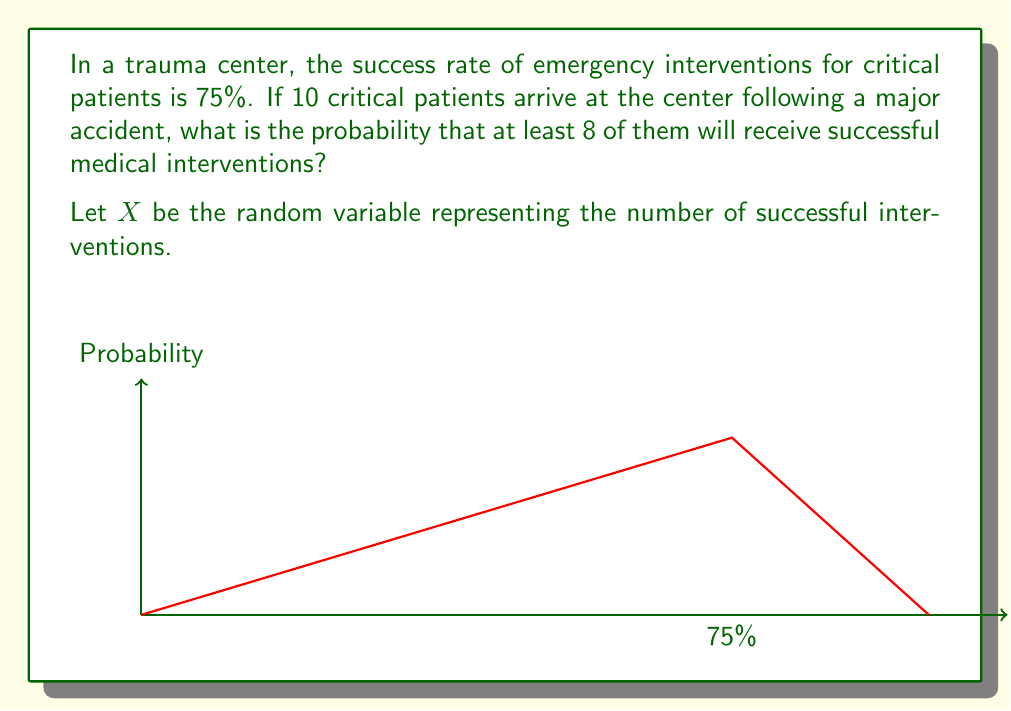Provide a solution to this math problem. To solve this problem, we'll use the binomial distribution, as we have a fixed number of independent trials (patients) with a constant probability of success for each trial.

1) First, we identify the parameters:
   n = 10 (number of patients)
   p = 0.75 (probability of successful intervention)
   q = 1 - p = 0.25 (probability of unsuccessful intervention)

2) We need to find P(X ≥ 8), which is equivalent to:
   P(X = 8) + P(X = 9) + P(X = 10)

3) The probability mass function for the binomial distribution is:
   $$P(X = k) = \binom{n}{k} p^k q^{n-k}$$

4) Let's calculate each probability:

   For X = 8:
   $$P(X = 8) = \binom{10}{8} (0.75)^8 (0.25)^2 = 45 \cdot 0.1001129150 \cdot 0.0625 = 0.2815300293$$

   For X = 9:
   $$P(X = 9) = \binom{10}{9} (0.75)^9 (0.25)^1 = 10 \cdot 0.0750846862 \cdot 0.25 = 0.1877117155$$

   For X = 10:
   $$P(X = 10) = \binom{10}{10} (0.75)^{10} (0.25)^0 = 1 \cdot 0.0563130147 \cdot 1 = 0.0563130147$$

5) Sum these probabilities:
   P(X ≥ 8) = 0.2815300293 + 0.1877117155 + 0.0563130147 = 0.5255547595

Therefore, the probability that at least 8 out of 10 critical patients will receive successful medical interventions is approximately 0.5256 or 52.56%.
Answer: 0.5256 